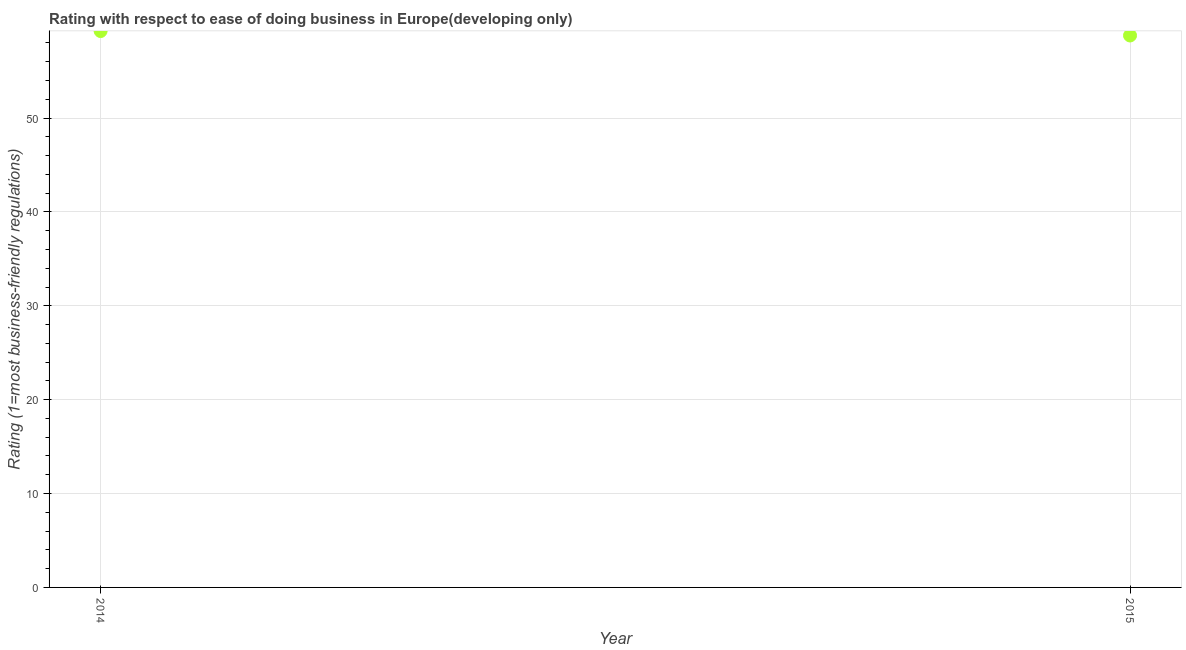What is the ease of doing business index in 2015?
Provide a succinct answer. 58.79. Across all years, what is the maximum ease of doing business index?
Make the answer very short. 59.26. Across all years, what is the minimum ease of doing business index?
Ensure brevity in your answer.  58.79. In which year was the ease of doing business index minimum?
Offer a terse response. 2015. What is the sum of the ease of doing business index?
Your answer should be very brief. 118.05. What is the difference between the ease of doing business index in 2014 and 2015?
Offer a very short reply. 0.47. What is the average ease of doing business index per year?
Provide a succinct answer. 59.03. What is the median ease of doing business index?
Your response must be concise. 59.03. In how many years, is the ease of doing business index greater than 12 ?
Ensure brevity in your answer.  2. What is the ratio of the ease of doing business index in 2014 to that in 2015?
Offer a terse response. 1.01. How many dotlines are there?
Offer a terse response. 1. How many years are there in the graph?
Ensure brevity in your answer.  2. Does the graph contain grids?
Make the answer very short. Yes. What is the title of the graph?
Ensure brevity in your answer.  Rating with respect to ease of doing business in Europe(developing only). What is the label or title of the X-axis?
Provide a short and direct response. Year. What is the label or title of the Y-axis?
Offer a terse response. Rating (1=most business-friendly regulations). What is the Rating (1=most business-friendly regulations) in 2014?
Keep it short and to the point. 59.26. What is the Rating (1=most business-friendly regulations) in 2015?
Keep it short and to the point. 58.79. What is the difference between the Rating (1=most business-friendly regulations) in 2014 and 2015?
Ensure brevity in your answer.  0.47. What is the ratio of the Rating (1=most business-friendly regulations) in 2014 to that in 2015?
Your answer should be compact. 1.01. 